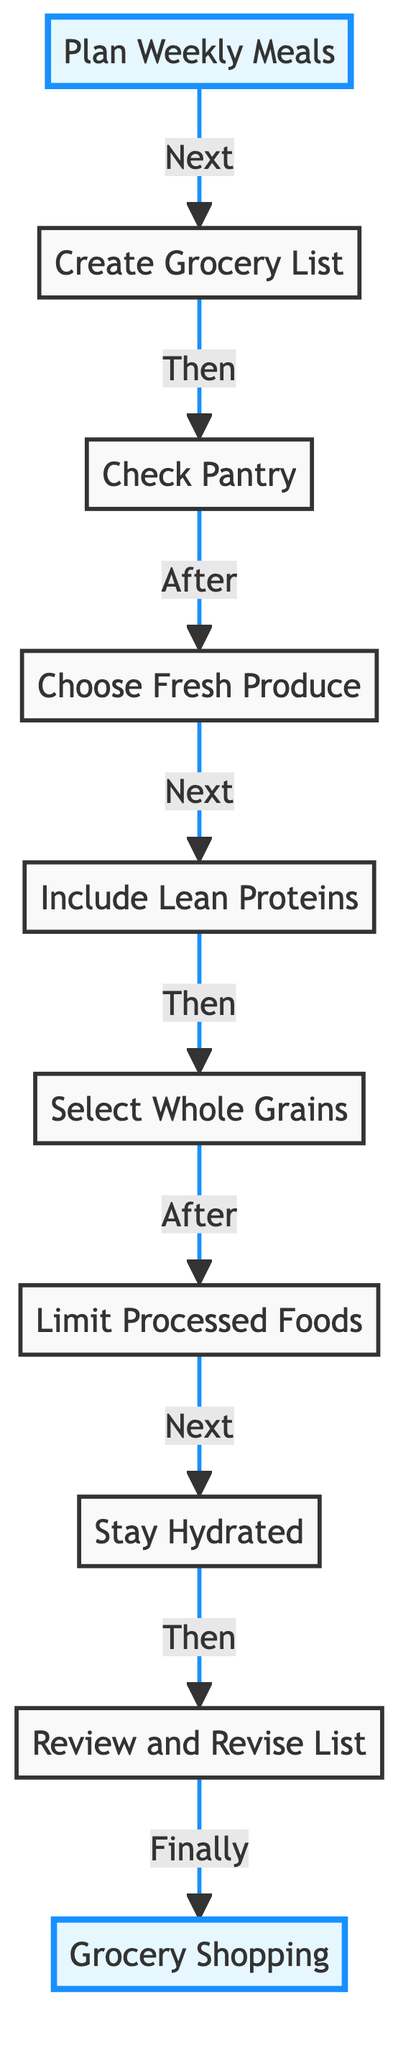What is the first step in the grocery shopping flow? The diagram starts with 'Plan Weekly Meals' as the initial step of the flow.
Answer: Plan Weekly Meals How many nodes are in the diagram? By counting all the elements listed in the diagram, we have a total of 10 nodes.
Answer: 10 Which step comes after 'Check Pantry'? The step immediately following 'Check Pantry' is 'Choose Fresh Produce', as indicated by the arrows connecting the nodes.
Answer: Choose Fresh Produce What is the last step before 'Grocery Shopping'? The last step before 'Grocery Shopping' is 'Review and Revise List', which connects directly to 'Grocery Shopping' in the flow.
Answer: Review and Revise List What is the relationship between 'Limit Processed Foods' and 'Stay Hydrated'? 'Limit Processed Foods' leads directly to 'Stay Hydrated', indicating a sequential flow in the grocery shopping process.
Answer: Sequential flow What is the primary focus of the step 'Choose Fresh Produce'? The description of 'Choose Fresh Produce' emphasizes selecting fruits and vegetables for optimal nutrition as its main focus.
Answer: Optimal nutrition What does the step 'Include Lean Proteins' emphasize in the grocery list? 'Include Lean Proteins' emphasizes adding healthy protein sources like chicken, fish, beans, and low-fat dairy to the grocery list.
Answer: Healthy protein sources How many steps are there between 'Plan Weekly Meals' and 'Grocery Shopping'? There are 8 steps between 'Plan Weekly Meals' and 'Grocery Shopping' when following the arrows in the diagram.
Answer: 8 steps What action follows after 'Stay Hydrated'? The action that follows 'Stay Hydrated' is 'Review and Revise List', continuing the sequence of steps in the flow.
Answer: Review and Revise List 